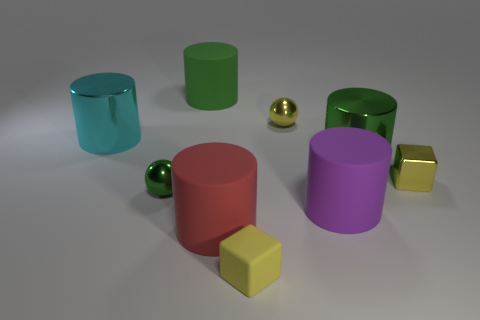Are there any tiny objects that have the same color as the tiny metal block?
Make the answer very short. Yes. Are there fewer large purple metallic objects than big red matte things?
Ensure brevity in your answer.  Yes. Is there a yellow cube made of the same material as the big red cylinder?
Give a very brief answer. Yes. There is a large shiny object that is left of the purple cylinder; what is its shape?
Ensure brevity in your answer.  Cylinder. Does the ball to the right of the small matte object have the same color as the small rubber object?
Provide a short and direct response. Yes. Are there fewer green matte cylinders that are in front of the tiny yellow shiny sphere than yellow rubber cylinders?
Your answer should be very brief. No. The other ball that is made of the same material as the yellow ball is what color?
Give a very brief answer. Green. There is a green thing to the right of the purple rubber cylinder; how big is it?
Offer a very short reply. Large. Does the tiny green ball have the same material as the tiny yellow sphere?
Provide a succinct answer. Yes. Are there any large matte cylinders in front of the yellow shiny object left of the big rubber cylinder to the right of the tiny yellow matte block?
Offer a terse response. Yes. 